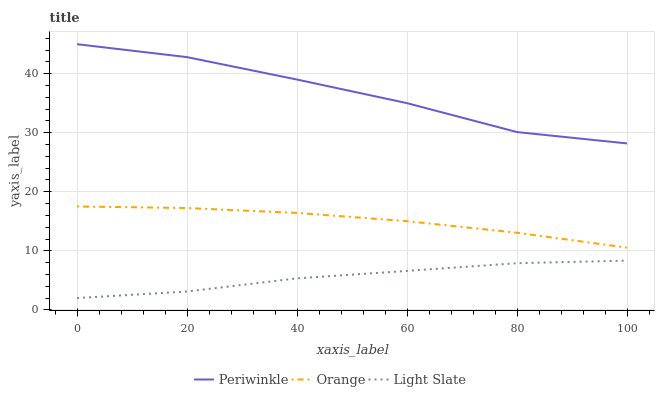Does Light Slate have the minimum area under the curve?
Answer yes or no. Yes. Does Periwinkle have the maximum area under the curve?
Answer yes or no. Yes. Does Periwinkle have the minimum area under the curve?
Answer yes or no. No. Does Light Slate have the maximum area under the curve?
Answer yes or no. No. Is Orange the smoothest?
Answer yes or no. Yes. Is Periwinkle the roughest?
Answer yes or no. Yes. Is Light Slate the smoothest?
Answer yes or no. No. Is Light Slate the roughest?
Answer yes or no. No. Does Light Slate have the lowest value?
Answer yes or no. Yes. Does Periwinkle have the lowest value?
Answer yes or no. No. Does Periwinkle have the highest value?
Answer yes or no. Yes. Does Light Slate have the highest value?
Answer yes or no. No. Is Orange less than Periwinkle?
Answer yes or no. Yes. Is Periwinkle greater than Orange?
Answer yes or no. Yes. Does Orange intersect Periwinkle?
Answer yes or no. No. 